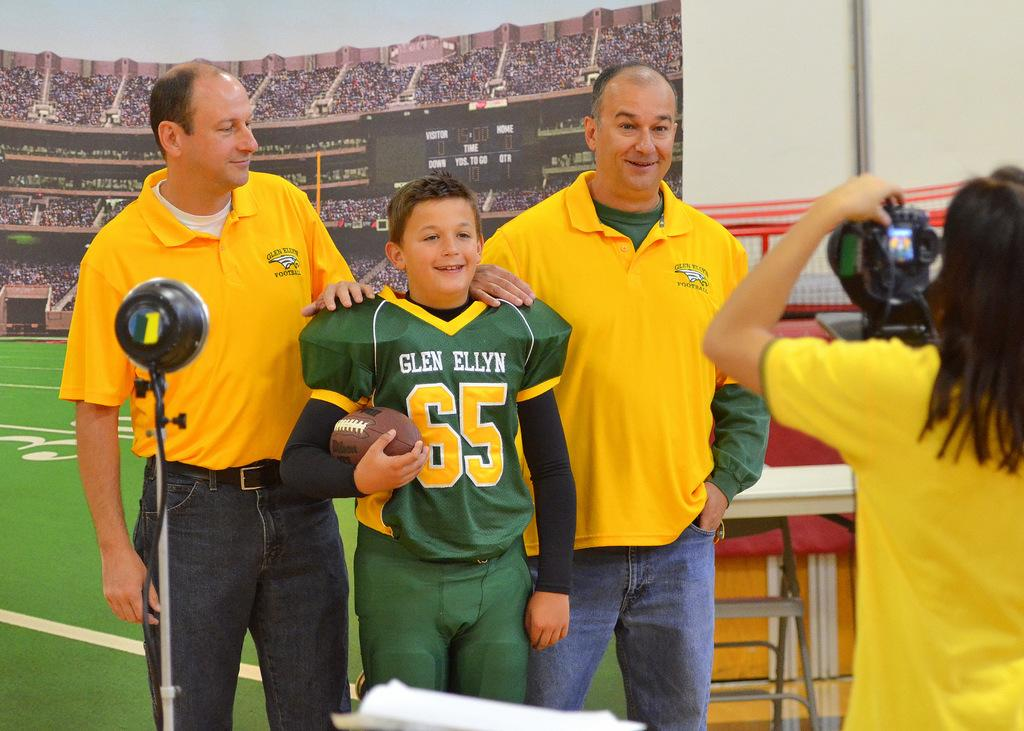<image>
Describe the image concisely. A young football player with a Glen Ellyn jersey on holds a football next to two men. 